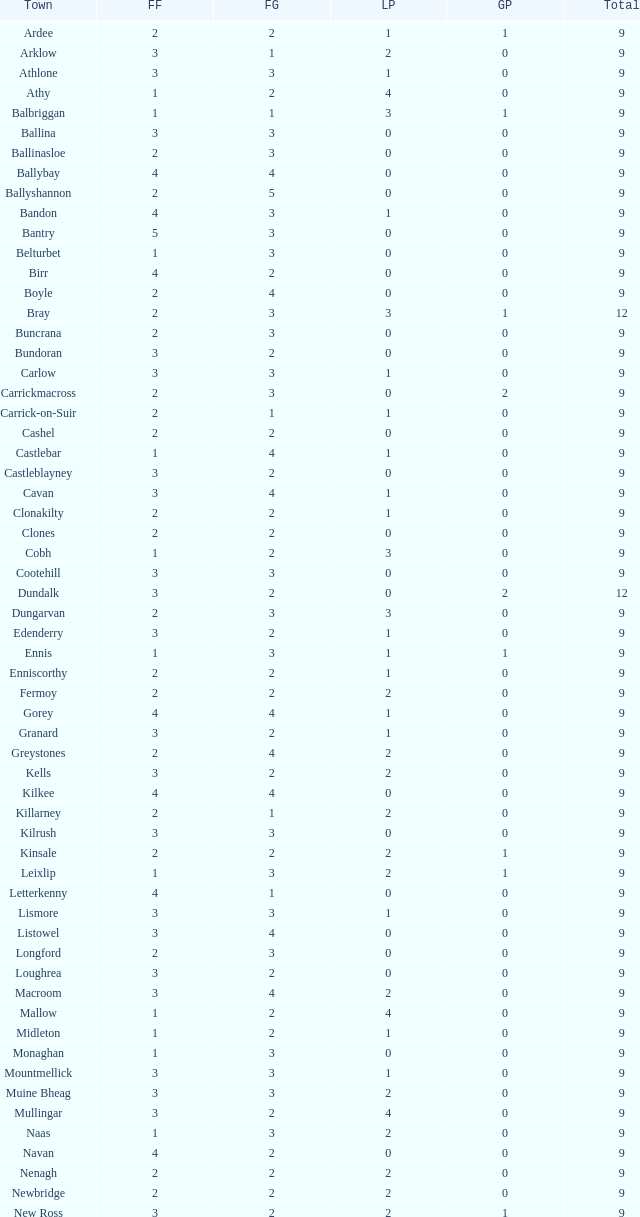How many are in the Green Party with a Fine Gael of less than 4 and a Fianna Fail of less than 2 in Athy? 0.0. 